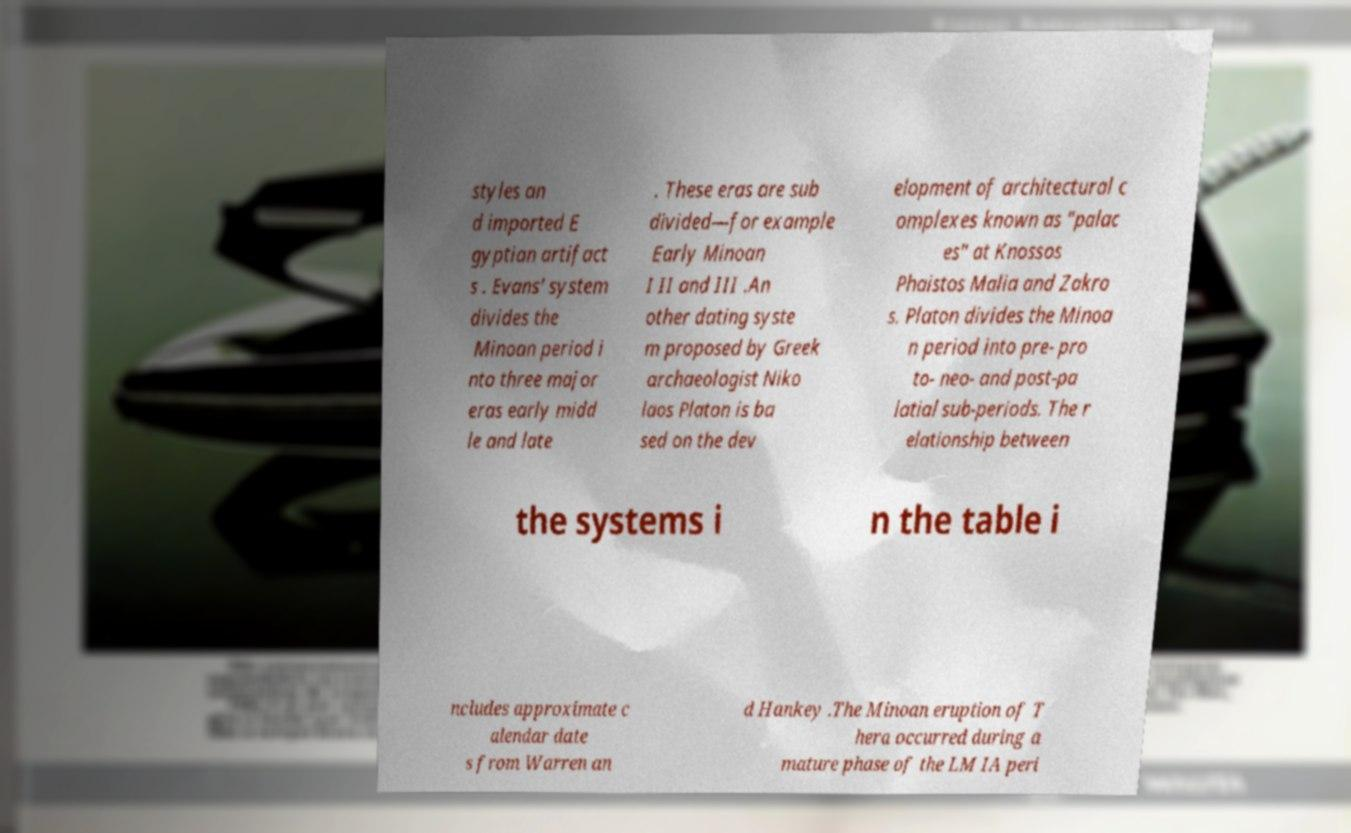There's text embedded in this image that I need extracted. Can you transcribe it verbatim? styles an d imported E gyptian artifact s . Evans' system divides the Minoan period i nto three major eras early midd le and late . These eras are sub divided—for example Early Minoan I II and III .An other dating syste m proposed by Greek archaeologist Niko laos Platon is ba sed on the dev elopment of architectural c omplexes known as "palac es" at Knossos Phaistos Malia and Zakro s. Platon divides the Minoa n period into pre- pro to- neo- and post-pa latial sub-periods. The r elationship between the systems i n the table i ncludes approximate c alendar date s from Warren an d Hankey .The Minoan eruption of T hera occurred during a mature phase of the LM IA peri 